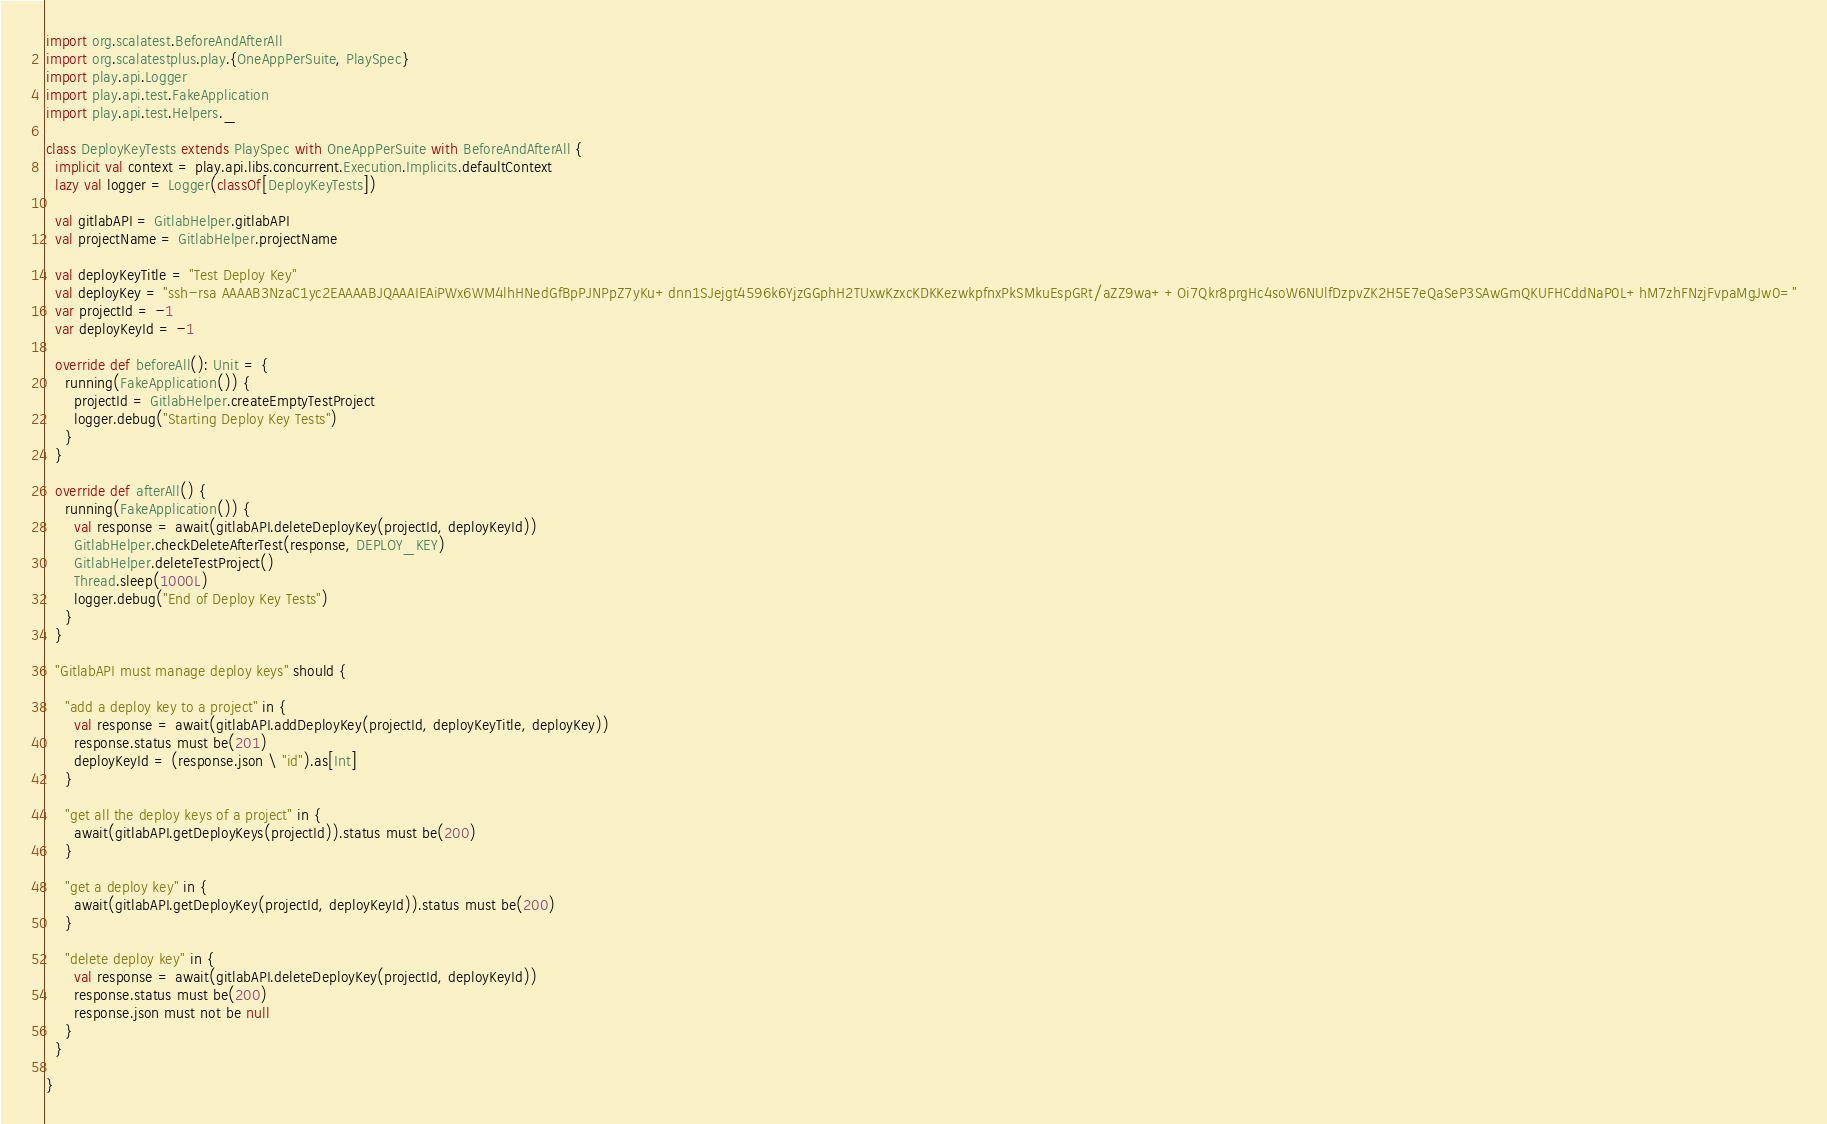Convert code to text. <code><loc_0><loc_0><loc_500><loc_500><_Scala_>import org.scalatest.BeforeAndAfterAll
import org.scalatestplus.play.{OneAppPerSuite, PlaySpec}
import play.api.Logger
import play.api.test.FakeApplication
import play.api.test.Helpers._

class DeployKeyTests extends PlaySpec with OneAppPerSuite with BeforeAndAfterAll {
  implicit val context = play.api.libs.concurrent.Execution.Implicits.defaultContext
  lazy val logger = Logger(classOf[DeployKeyTests])

  val gitlabAPI = GitlabHelper.gitlabAPI
  val projectName = GitlabHelper.projectName

  val deployKeyTitle = "Test Deploy Key"
  val deployKey = "ssh-rsa AAAAB3NzaC1yc2EAAAABJQAAAIEAiPWx6WM4lhHNedGfBpPJNPpZ7yKu+dnn1SJejgt4596k6YjzGGphH2TUxwKzxcKDKKezwkpfnxPkSMkuEspGRt/aZZ9wa++Oi7Qkr8prgHc4soW6NUlfDzpvZK2H5E7eQaSeP3SAwGmQKUFHCddNaP0L+hM7zhFNzjFvpaMgJw0="
  var projectId = -1
  var deployKeyId = -1

  override def beforeAll(): Unit = {
    running(FakeApplication()) {
      projectId = GitlabHelper.createEmptyTestProject
      logger.debug("Starting Deploy Key Tests")
    }
  }

  override def afterAll() {
    running(FakeApplication()) {
      val response = await(gitlabAPI.deleteDeployKey(projectId, deployKeyId))
      GitlabHelper.checkDeleteAfterTest(response, DEPLOY_KEY)
      GitlabHelper.deleteTestProject()
      Thread.sleep(1000L)
      logger.debug("End of Deploy Key Tests")
    }
  }

  "GitlabAPI must manage deploy keys" should {

    "add a deploy key to a project" in {
      val response = await(gitlabAPI.addDeployKey(projectId, deployKeyTitle, deployKey))
      response.status must be(201)
      deployKeyId = (response.json \ "id").as[Int]
    }

    "get all the deploy keys of a project" in {
      await(gitlabAPI.getDeployKeys(projectId)).status must be(200)
    }

    "get a deploy key" in {
      await(gitlabAPI.getDeployKey(projectId, deployKeyId)).status must be(200)
    }

    "delete deploy key" in {
      val response = await(gitlabAPI.deleteDeployKey(projectId, deployKeyId))
      response.status must be(200)
      response.json must not be null
    }
  }

}
</code> 